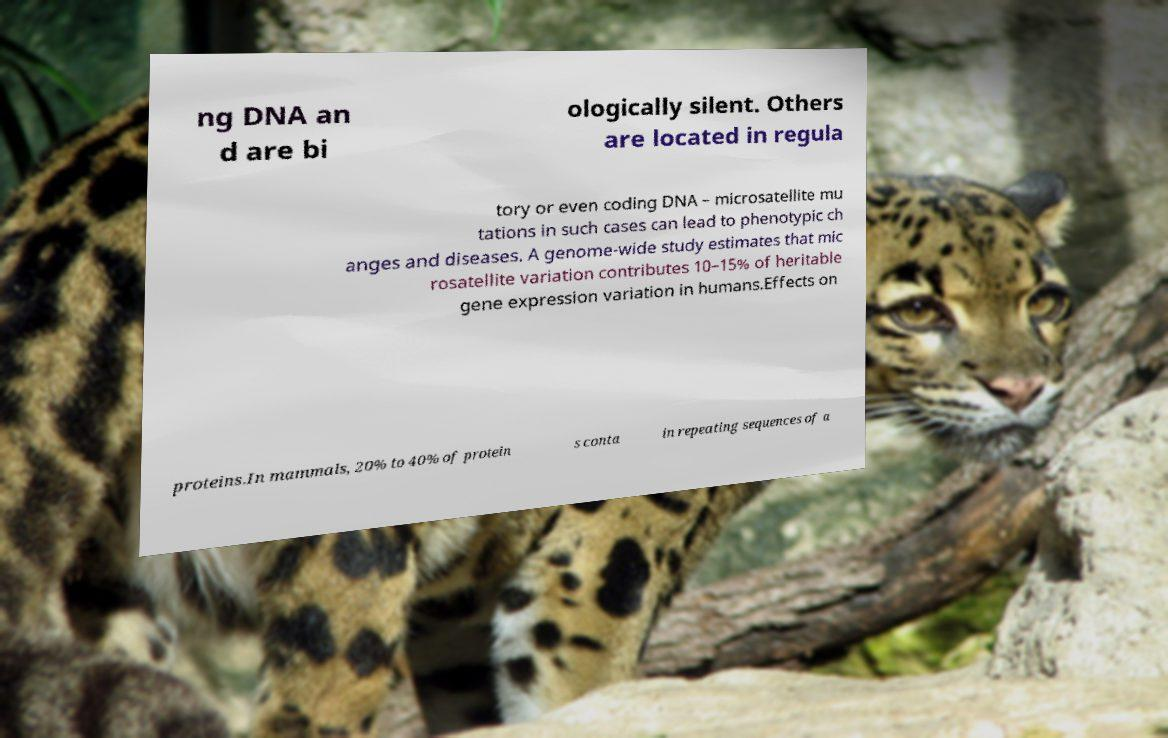Can you read and provide the text displayed in the image?This photo seems to have some interesting text. Can you extract and type it out for me? ng DNA an d are bi ologically silent. Others are located in regula tory or even coding DNA – microsatellite mu tations in such cases can lead to phenotypic ch anges and diseases. A genome-wide study estimates that mic rosatellite variation contributes 10–15% of heritable gene expression variation in humans.Effects on proteins.In mammals, 20% to 40% of protein s conta in repeating sequences of a 